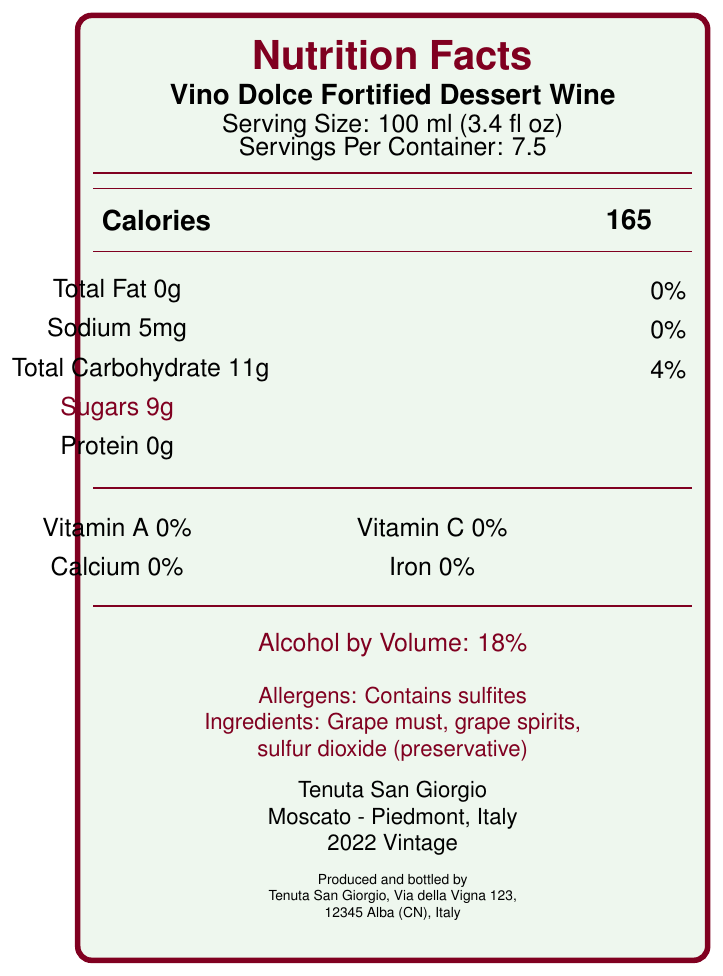how many calories are in one serving of Vino Dolce Fortified Dessert Wine? According to the document, the number of calories per serving is listed as 165.
Answer: 165 what is the serving size for Vino Dolce Fortified Dessert Wine? The serving size is specified in the document as 100 ml (3.4 fl oz).
Answer: 100 ml (3.4 fl oz) how much alcohol does Vino Dolce Fortified Dessert Wine contain per volume? The document states that the alcohol by volume (ABV) for the wine is 18%.
Answer: 18% what are the main ingredients in Vino Dolce Fortified Dessert Wine? The document lists the main ingredients as grape must, grape spirits, and sulfur dioxide (preservative).
Answer: Grape must, grape spirits, sulfur dioxide (preservative) does Vino Dolce Fortified Dessert Wine contain any protein? The document indicates that the amount of protein per serving is 0g.
Answer: No which vineyard produces Vino Dolce Fortified Dessert Wine? A. Tenuta Santa Maria B. Tenuta San Giorgio C. Tenuta di Vino D. San Giorgio Estates The document clearly states that the vineyard name is Tenuta San Giorgio.
Answer: B how many grams of sugars are in one serving of Vino Dolce Fortified Dessert Wine? A. 0g B. 5g C. 9g D. 11g The document lists the amount of sugars per serving as 9g.
Answer: C is Vino Dolce Fortified Dessert Wine organic? The document states that the wine has certifications including "DOC" and "Organic."
Answer: Yes does Vino Dolce Fortified Dessert Wine have any vitamin content? According to the document, the wine contains 0% Vitamin A, 0% Vitamin C, 0% calcium, and 0% iron.
Answer: No how many servings are there per container of Vino Dolce Fortified Dessert Wine? The document specifies that there are 7.5 servings per container.
Answer: 7.5 what varietal of grape is used in Vino Dolce Fortified Dessert Wine? The document indicates that the varietal used is Moscato.
Answer: Moscato where is Vino Dolce Fortified Dessert Wine produced? The document lists the region of origin as Piedmont, Italy.
Answer: Piedmont, Italy who is the winemaker of Vino Dolce Fortified Dessert Wine? The document names Giorgio Rossi as the winemaker.
Answer: Giorgio Rossi how should Vino Dolce Fortified Dessert Wine be stored? The document provides storage instructions: Store in a cool, dark place. Serve chilled.
Answer: Store in a cool, dark place. Serve chilled. what are the pairing recommendations for Vino Dolce Fortified Dessert Wine? The document suggests pairing the wine with desserts, blue cheeses, or using it as an aperitif.
Answer: Ideal with desserts, blue cheeses, or as an aperitif which award did Vino Dolce Fortified Dessert Wine win in 2023? The document notes that the wine won a Gold Medal at the Decanter World Wine Awards 2023.
Answer: Gold Medal - Decanter World Wine Awards 2023 what percentage of total carbohydrates does one serving of Vino Dolce Fortified Dessert Wine provide? The document indicates that one serving contains 11g of total carbohydrates, which is 4% of the daily value.
Answer: 4% how does Vino Dolce Fortified Dessert Wine incorporate sustainability practices? The document mentions that the wine is produced using solar energy and sustainable farming practices.
Answer: Produced using solar energy and sustainable farming practices what is the vintage year of Vino Dolce Fortified Dessert Wine? The document specifies the vintage year as 2022.
Answer: 2022 what is the total fat content in a serving of Vino Dolce Fortified Dessert Wine? The document states that the total fat content per serving is 0g.
Answer: 0g does the wine contain any allergens? The document states that the wine contains sulfites as an allergen.
Answer: Yes what is the main idea of the Nutrition Facts Label for Vino Dolce Fortified Dessert Wine? The document offers comprehensive information including nutritional values, ingredients, certifications, awards, storage instructions, pairing recommendations, and winemaker details.
Answer: The Nutrition Facts Label provides detailed nutritional information, serving size, ingredients, alcohol content, and additional relevant details about Vino Dolce Fortified Dessert Wine. where can you find contact information for Tenuta San Giorgio? The specific contact information such as email or phone number is not provided in the rendered document; only the address is mentioned.
Answer: Could not be determined 